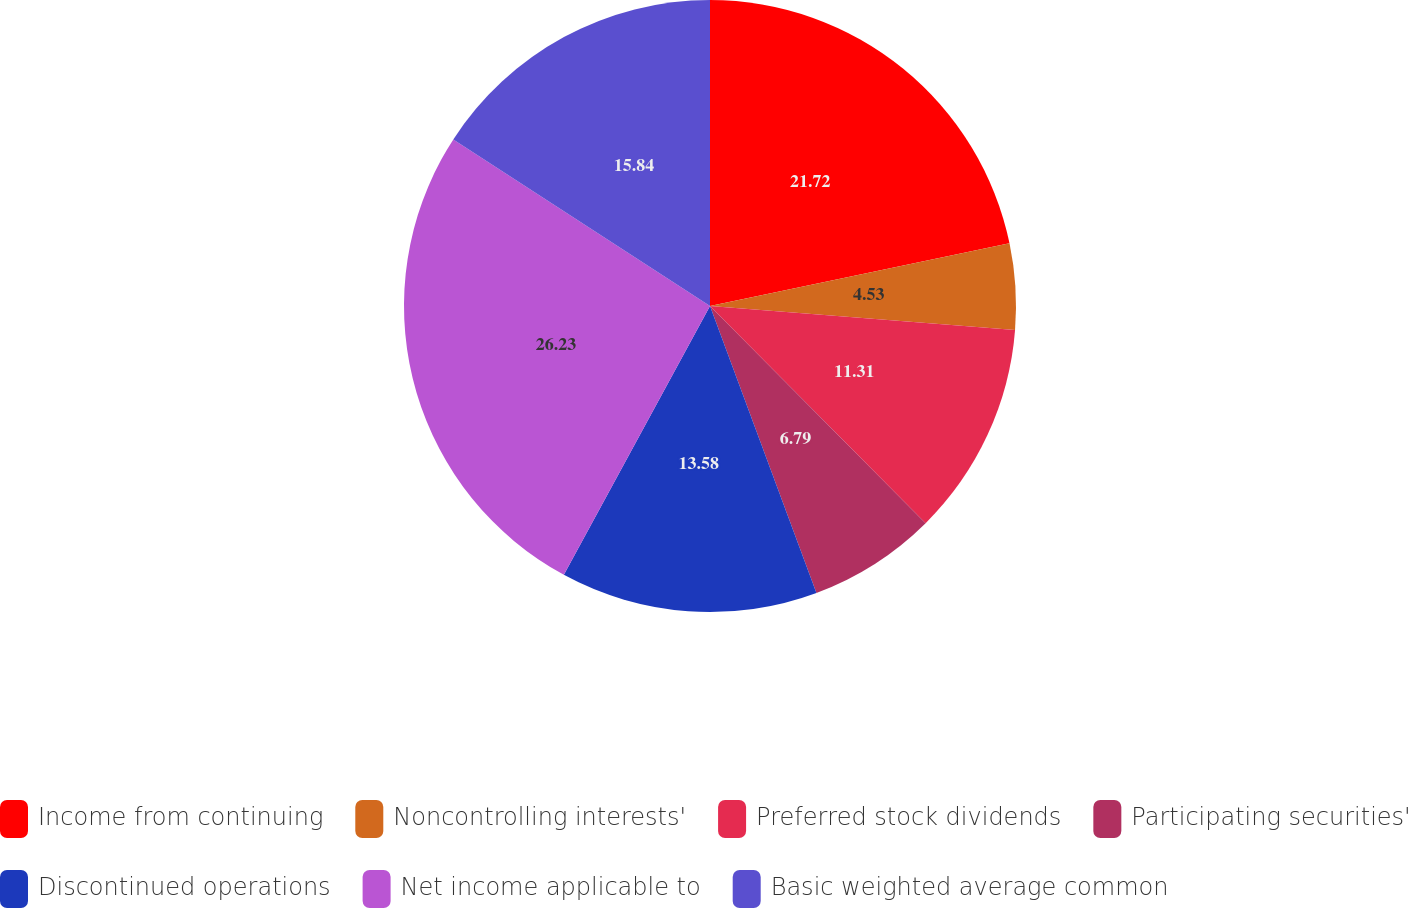Convert chart to OTSL. <chart><loc_0><loc_0><loc_500><loc_500><pie_chart><fcel>Income from continuing<fcel>Noncontrolling interests'<fcel>Preferred stock dividends<fcel>Participating securities'<fcel>Discontinued operations<fcel>Net income applicable to<fcel>Basic weighted average common<nl><fcel>21.72%<fcel>4.53%<fcel>11.31%<fcel>6.79%<fcel>13.58%<fcel>26.24%<fcel>15.84%<nl></chart> 